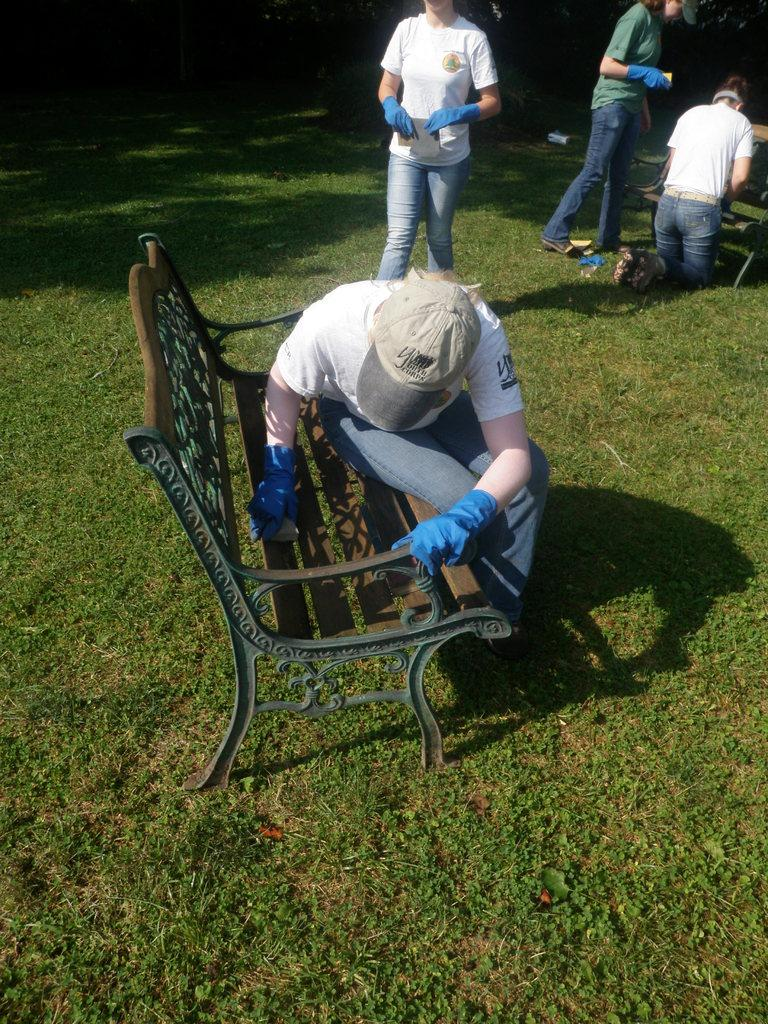What is the man in the image doing? The man is sitting on a bench in the image. What can be seen in the background of the image? There are people standing in the background of the image. What type of surface is the man sitting on? There is grass on the floor in the image. What type of pet is the man holding in the image? There is no pet visible in the image; the man is simply sitting on a bench. 